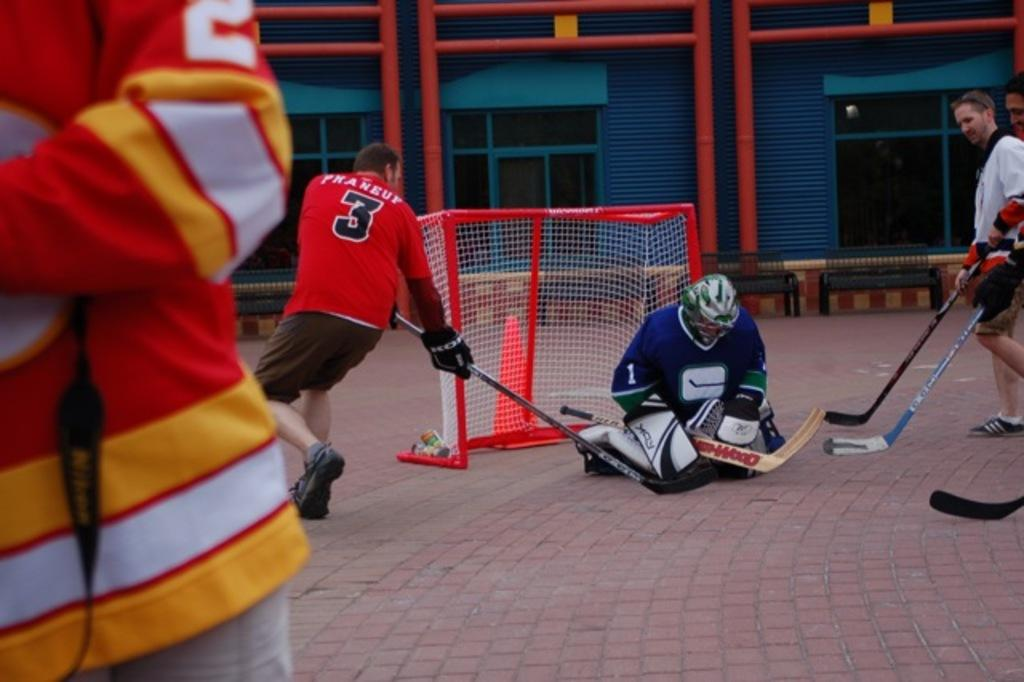<image>
Create a compact narrative representing the image presented. a hockey play trying to score with praneuf on the back of his jersey 